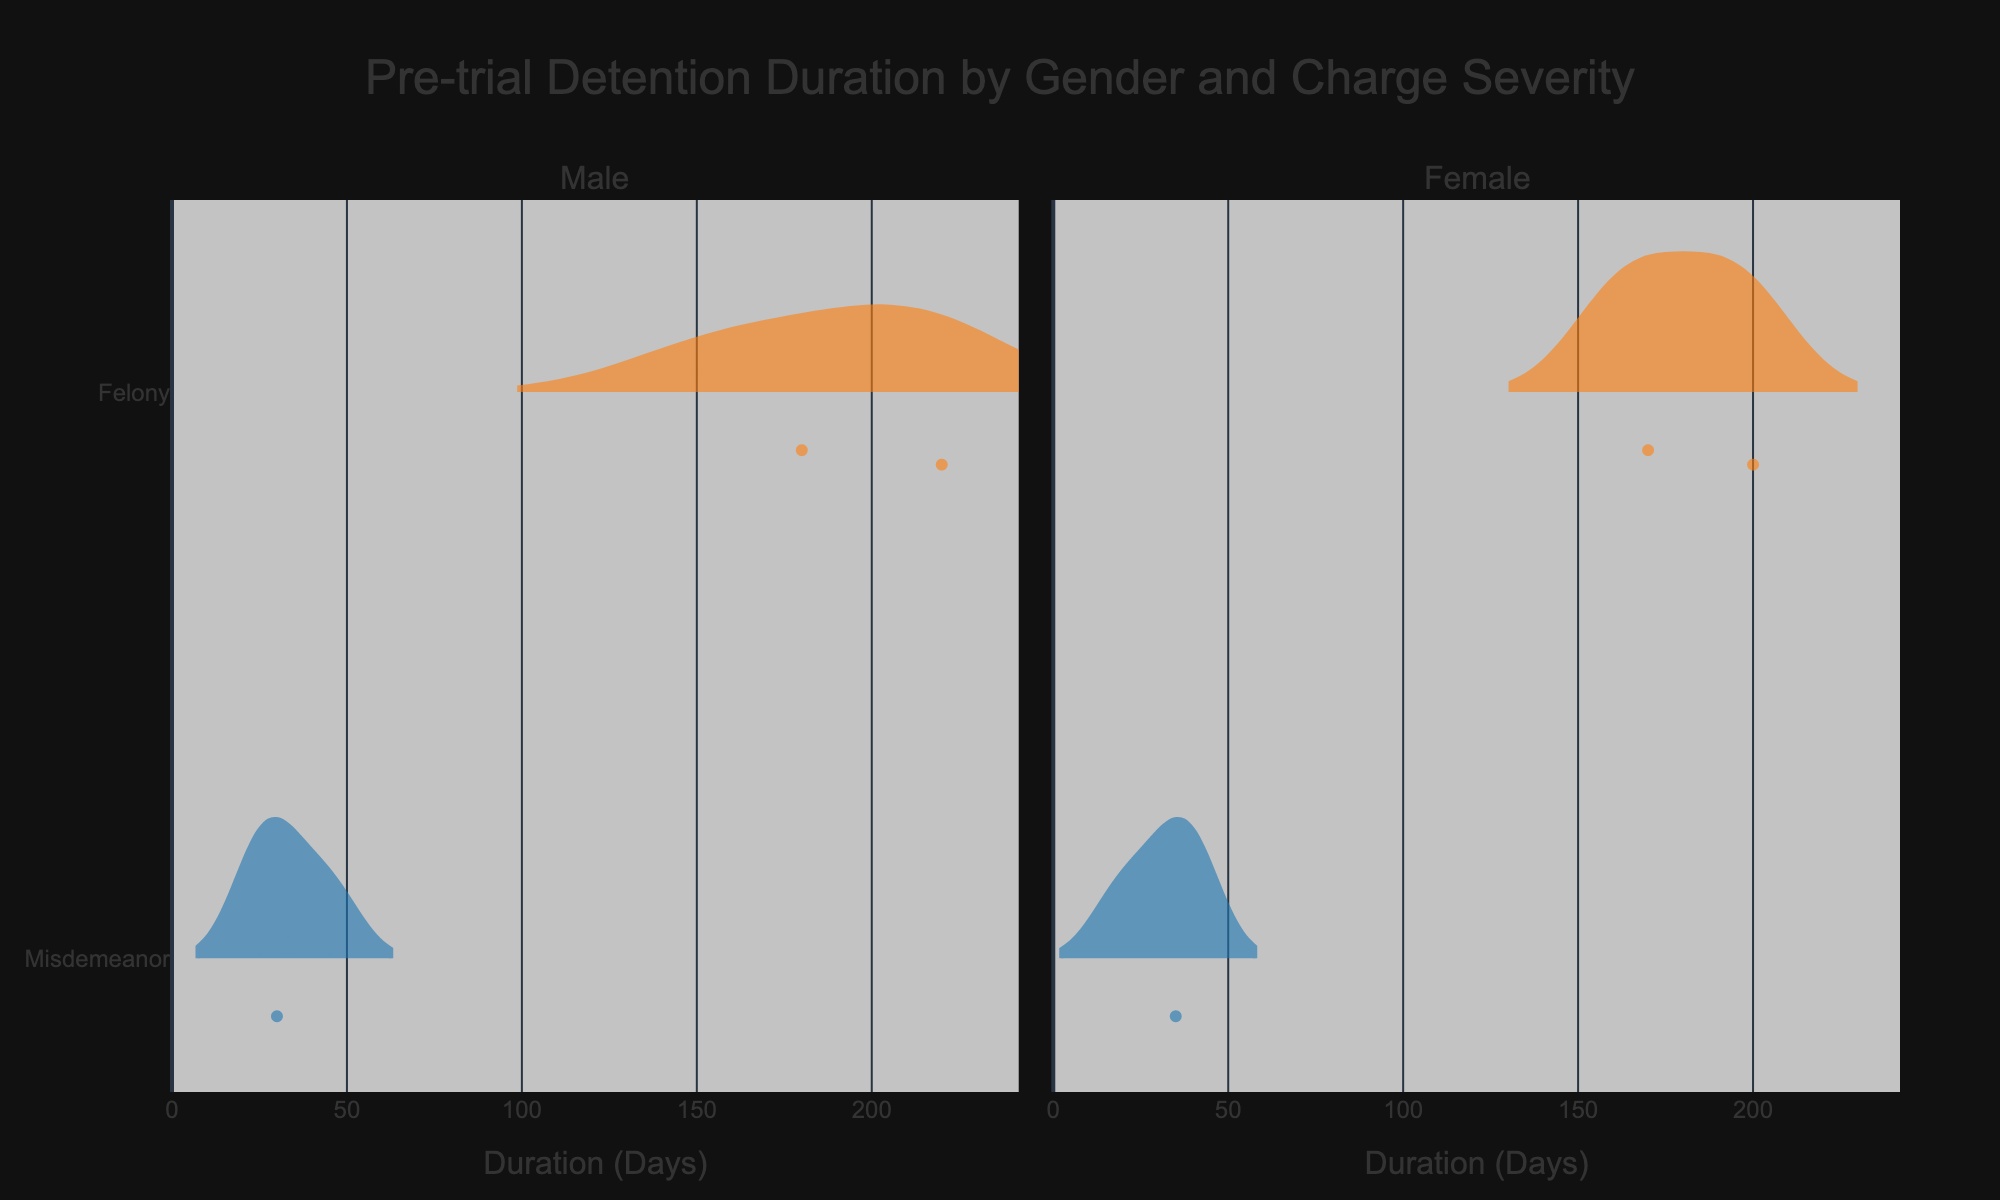What's the title of the chart? The title is positioned at the top center of the chart and is usually the largest text on the figure. Here, it is clearly written.
Answer: Pre-trial Detention Duration by Gender and Charge Severity How are the charge severities represented visually? Each charge severity is represented by a different color. By looking at the figure, we can see that 'Misdemeanor' and 'Felony' are differentiated by their colors.
Answer: Different colors What's the range of the x-axis? The x-axis represents the Duration in Days, and its range can be determined by looking at the axis labels and ticks.
Answer: 0 to around 230 days Which gender has a longer median pre-trial detention duration for felonies? By analyzing the median lines in the violin plots for felonies, we can compare the positions for males and females.
Answer: Male How many data points are there for males with misdemeanor charges? Each data point within the violin plot is indicated by a jittered dot. By counting these dots in the appropriate section, we can determine the number of data points.
Answer: 3 Which gender shows more variability in pre-trial detention durations for misdemeanor charges? Variability can be assessed through the spread of the violin plot. We compare the width and spread of the plots for males and females charged with misdemeanors.
Answer: Female What is the median pre-trial detention duration for females charged with misdemeanors? The median is depicted by the horizontal line within the violin plot. Looking at the plot for females with misdemeanors, we identify the value of the median line.
Answer: 35 days Compare the distribution shapes for felony charges between males and females. By examining the overall shapes of the violin plots, we can assess similarities and differences in distributions, such as symmetry, peaks, and spread.
Answer: Similar shape, but males have slightly wider spread Is there an outlier in the pre-trial detention duration for any category? Outliers are typically shown as individual points that are distinctly separate from the main distribution in the violin plot. By scanning the plot, we can identify any such points.
Answer: No outliers visible What is the maximum pre-trial detention duration observed for males charged with felonies? The maximum value is at the upper end of the distribution in the violin plot. We look at the highest point within the male felony category.
Answer: 220 days 